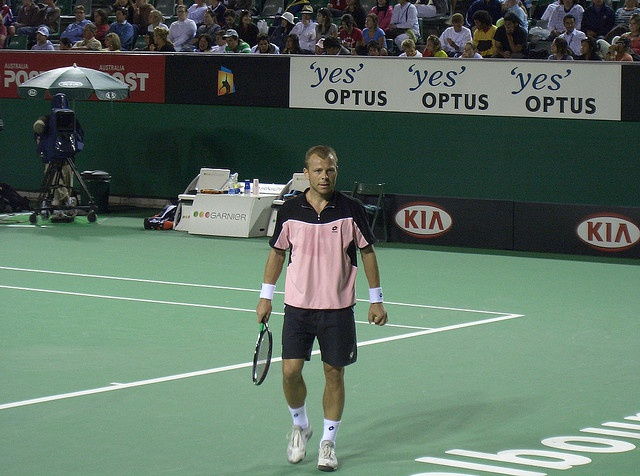Describe the objects in this image and their specific colors. I can see people in black, pink, darkgray, and gray tones, people in black and gray tones, umbrella in black, darkgray, lightgray, and gray tones, chair in black and purple tones, and tennis racket in black, gray, and darkgray tones in this image. 